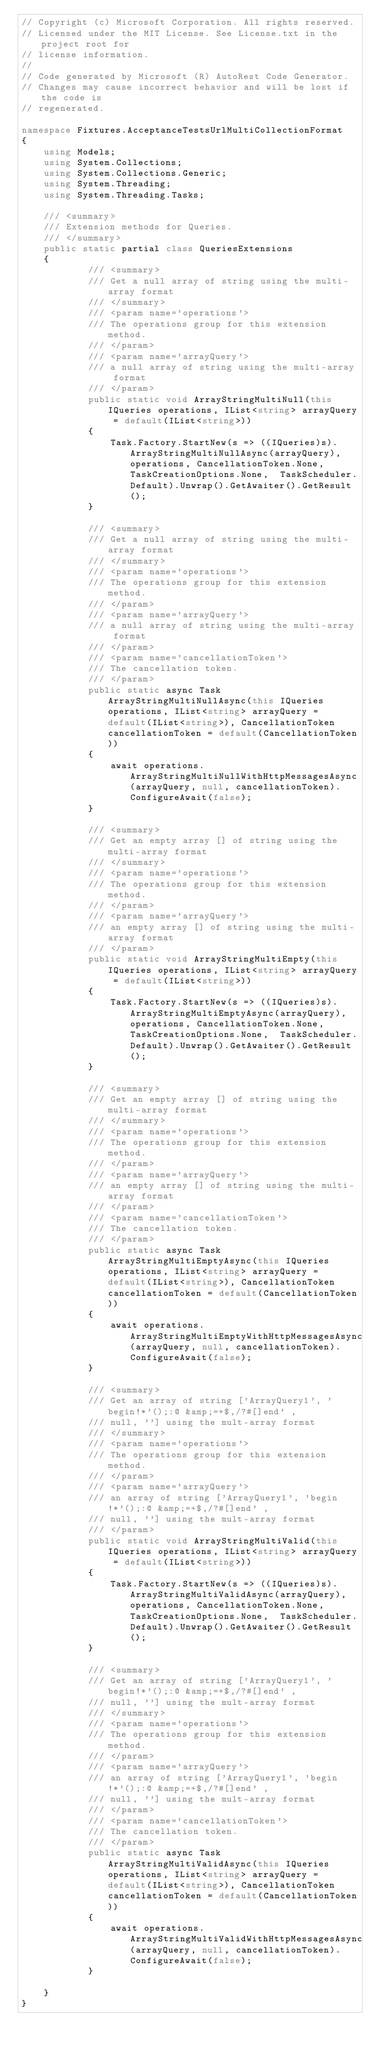<code> <loc_0><loc_0><loc_500><loc_500><_C#_>// Copyright (c) Microsoft Corporation. All rights reserved.
// Licensed under the MIT License. See License.txt in the project root for
// license information.
//
// Code generated by Microsoft (R) AutoRest Code Generator.
// Changes may cause incorrect behavior and will be lost if the code is
// regenerated.

namespace Fixtures.AcceptanceTestsUrlMultiCollectionFormat
{
    using Models;
    using System.Collections;
    using System.Collections.Generic;
    using System.Threading;
    using System.Threading.Tasks;

    /// <summary>
    /// Extension methods for Queries.
    /// </summary>
    public static partial class QueriesExtensions
    {
            /// <summary>
            /// Get a null array of string using the multi-array format
            /// </summary>
            /// <param name='operations'>
            /// The operations group for this extension method.
            /// </param>
            /// <param name='arrayQuery'>
            /// a null array of string using the multi-array format
            /// </param>
            public static void ArrayStringMultiNull(this IQueries operations, IList<string> arrayQuery = default(IList<string>))
            {
                Task.Factory.StartNew(s => ((IQueries)s).ArrayStringMultiNullAsync(arrayQuery), operations, CancellationToken.None, TaskCreationOptions.None,  TaskScheduler.Default).Unwrap().GetAwaiter().GetResult();
            }

            /// <summary>
            /// Get a null array of string using the multi-array format
            /// </summary>
            /// <param name='operations'>
            /// The operations group for this extension method.
            /// </param>
            /// <param name='arrayQuery'>
            /// a null array of string using the multi-array format
            /// </param>
            /// <param name='cancellationToken'>
            /// The cancellation token.
            /// </param>
            public static async Task ArrayStringMultiNullAsync(this IQueries operations, IList<string> arrayQuery = default(IList<string>), CancellationToken cancellationToken = default(CancellationToken))
            {
                await operations.ArrayStringMultiNullWithHttpMessagesAsync(arrayQuery, null, cancellationToken).ConfigureAwait(false);
            }

            /// <summary>
            /// Get an empty array [] of string using the multi-array format
            /// </summary>
            /// <param name='operations'>
            /// The operations group for this extension method.
            /// </param>
            /// <param name='arrayQuery'>
            /// an empty array [] of string using the multi-array format
            /// </param>
            public static void ArrayStringMultiEmpty(this IQueries operations, IList<string> arrayQuery = default(IList<string>))
            {
                Task.Factory.StartNew(s => ((IQueries)s).ArrayStringMultiEmptyAsync(arrayQuery), operations, CancellationToken.None, TaskCreationOptions.None,  TaskScheduler.Default).Unwrap().GetAwaiter().GetResult();
            }

            /// <summary>
            /// Get an empty array [] of string using the multi-array format
            /// </summary>
            /// <param name='operations'>
            /// The operations group for this extension method.
            /// </param>
            /// <param name='arrayQuery'>
            /// an empty array [] of string using the multi-array format
            /// </param>
            /// <param name='cancellationToken'>
            /// The cancellation token.
            /// </param>
            public static async Task ArrayStringMultiEmptyAsync(this IQueries operations, IList<string> arrayQuery = default(IList<string>), CancellationToken cancellationToken = default(CancellationToken))
            {
                await operations.ArrayStringMultiEmptyWithHttpMessagesAsync(arrayQuery, null, cancellationToken).ConfigureAwait(false);
            }

            /// <summary>
            /// Get an array of string ['ArrayQuery1', 'begin!*'();:@ &amp;=+$,/?#[]end' ,
            /// null, ''] using the mult-array format
            /// </summary>
            /// <param name='operations'>
            /// The operations group for this extension method.
            /// </param>
            /// <param name='arrayQuery'>
            /// an array of string ['ArrayQuery1', 'begin!*'();:@ &amp;=+$,/?#[]end' ,
            /// null, ''] using the mult-array format
            /// </param>
            public static void ArrayStringMultiValid(this IQueries operations, IList<string> arrayQuery = default(IList<string>))
            {
                Task.Factory.StartNew(s => ((IQueries)s).ArrayStringMultiValidAsync(arrayQuery), operations, CancellationToken.None, TaskCreationOptions.None,  TaskScheduler.Default).Unwrap().GetAwaiter().GetResult();
            }

            /// <summary>
            /// Get an array of string ['ArrayQuery1', 'begin!*'();:@ &amp;=+$,/?#[]end' ,
            /// null, ''] using the mult-array format
            /// </summary>
            /// <param name='operations'>
            /// The operations group for this extension method.
            /// </param>
            /// <param name='arrayQuery'>
            /// an array of string ['ArrayQuery1', 'begin!*'();:@ &amp;=+$,/?#[]end' ,
            /// null, ''] using the mult-array format
            /// </param>
            /// <param name='cancellationToken'>
            /// The cancellation token.
            /// </param>
            public static async Task ArrayStringMultiValidAsync(this IQueries operations, IList<string> arrayQuery = default(IList<string>), CancellationToken cancellationToken = default(CancellationToken))
            {
                await operations.ArrayStringMultiValidWithHttpMessagesAsync(arrayQuery, null, cancellationToken).ConfigureAwait(false);
            }

    }
}

</code> 